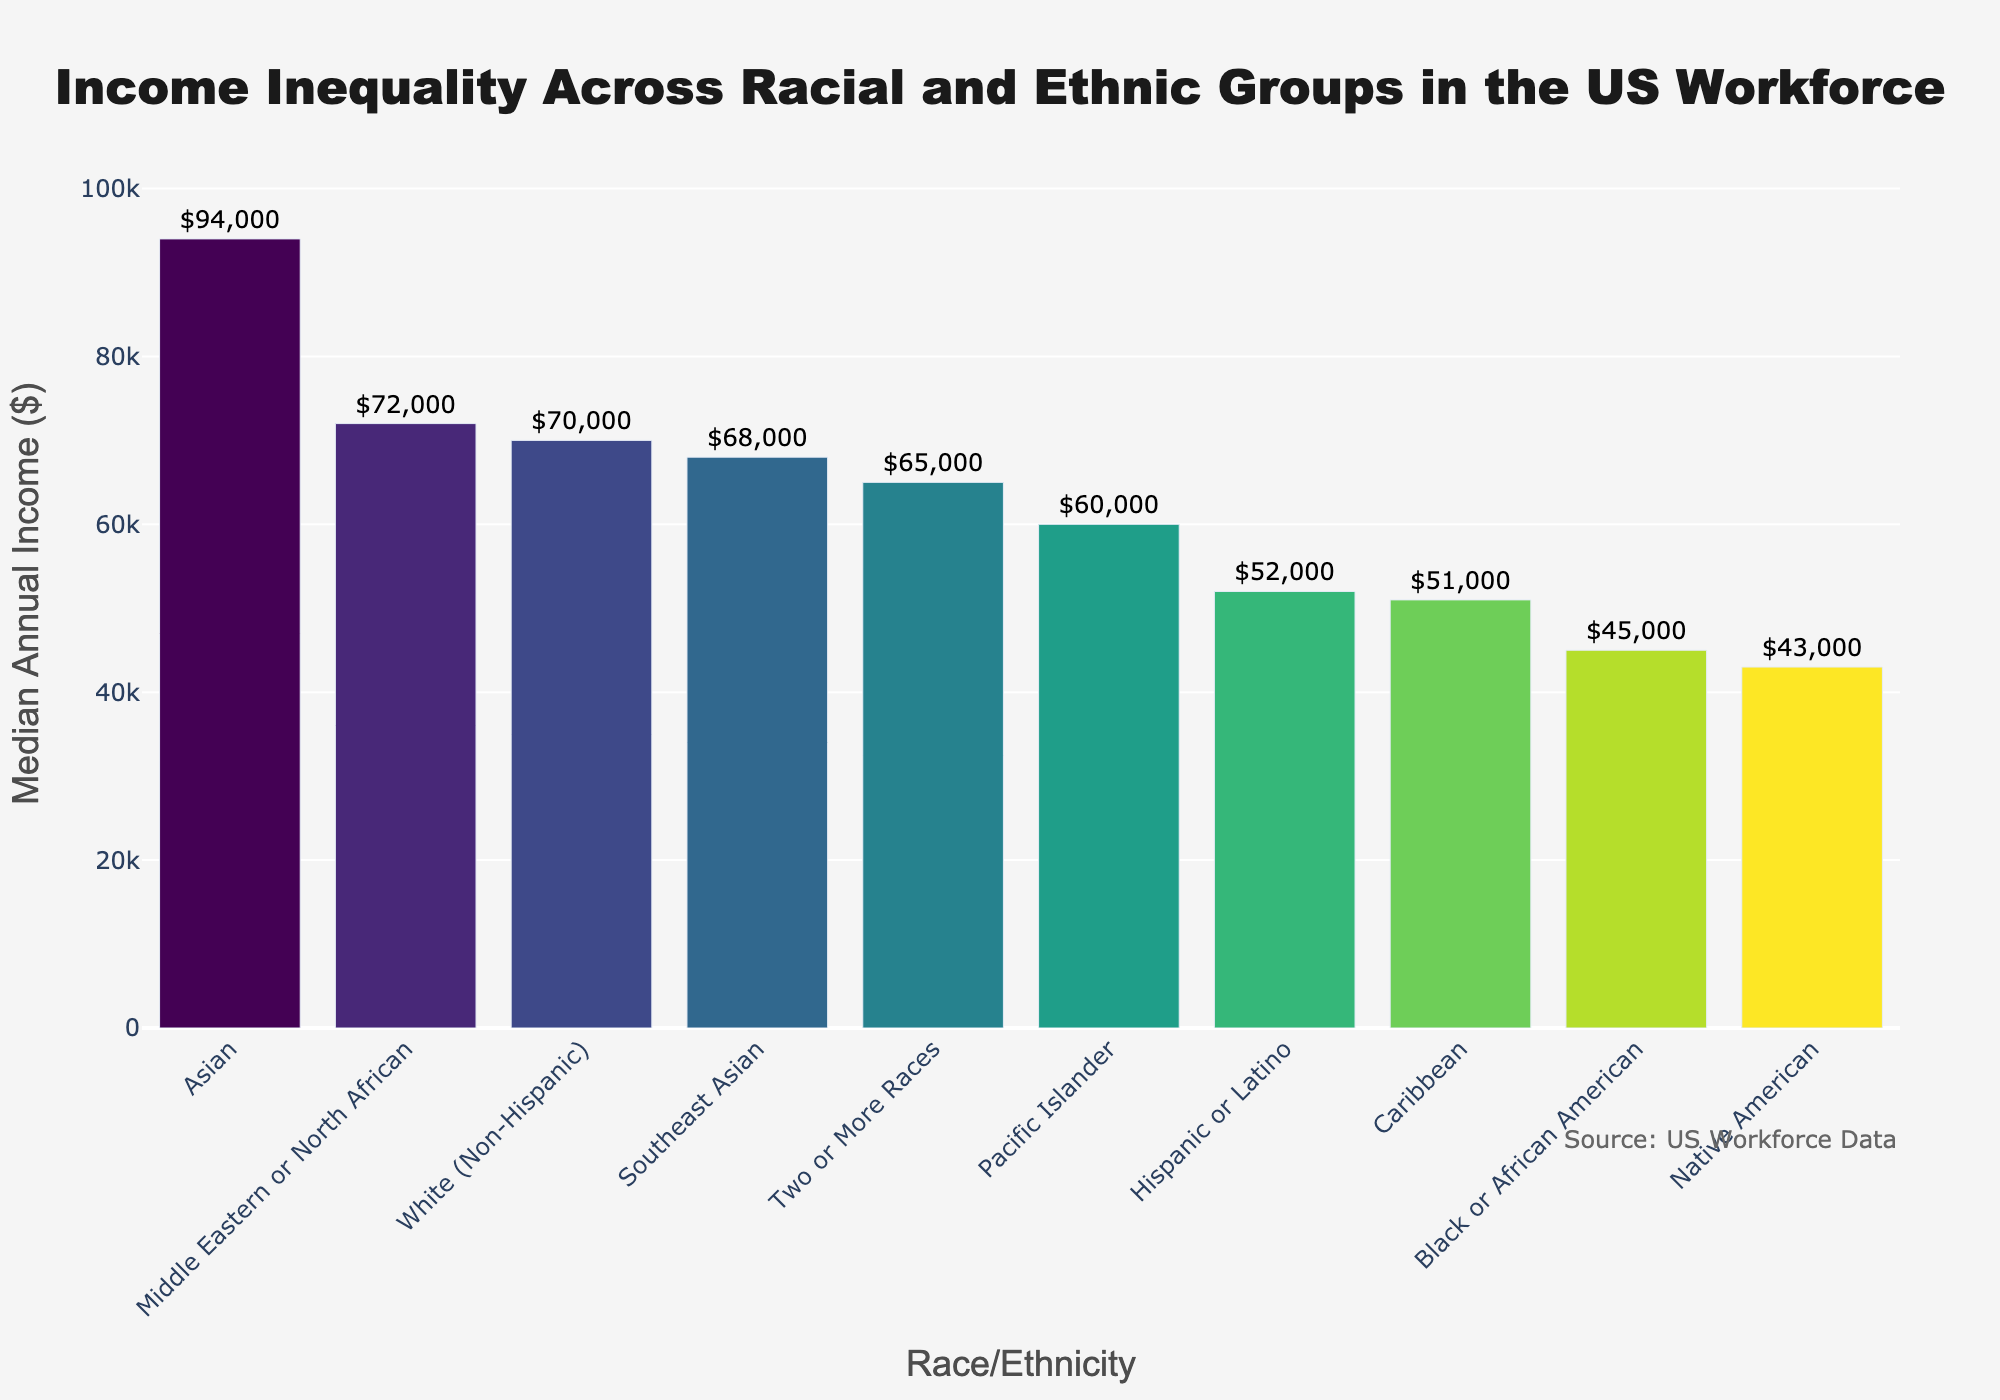Which racial or ethnic group has the highest median annual income? By observing the highest bar in the bar chart, we can identify the group with the highest median annual income. The tallest bar belongs to the Asian group, indicating that they have the highest median income.
Answer: Asian Which racial or ethnic group has the lowest median annual income? By looking at the shortest bar in the chart, one can determine the group with the lowest median annual income. The shortest bar is associated with Native American, indicating they have the lowest median income.
Answer: Native American What is the difference in median income between the group with the highest income and the group with the lowest income? The group with the highest median annual income is Asian ($94,000) and the group with the lowest is Native American ($43,000). The difference is calculated as $94,000 - $43,000.
Answer: $51,000 Compare the median annual income of Hispanic or Latino and Native American groups. Which group has a higher income and by how much? From the chart, the median annual income for Hispanic or Latino is $52,000 and for Native American is $43,000. The difference is $52,000 - $43,000.
Answer: Hispanic or Latino by $9,000 What is the combined median income of the White (Non-Hispanic) and Black or African American groups? The median income for White (Non-Hispanic) is $70,000 and for Black or African American is $45,000. Summing these values gives $70,000 + $45,000.
Answer: $115,000 Which group has a median income closest to the overall median when considering all groups? First, arrange the median incomes in ascending order: $43,000, $45,000, $51,000, $52,000, $60,000, $65,000, $68,000, $70,000, $72,000, $94,000. With 10 groups, the median would be the average of the 5th and 6th values in this list, i.e., ($60,000 + $65,000) / 2, which is closest to the income of Two or More Races.
Answer: Two or More Races Which groups have a median annual income greater than $65,000? Observing the chart, the groups with incomes higher than $65,000 are Two or More Races ($65,000 is equal), Southeast Asian ($68,000), White (Non-Hispanic) ($70,000), Middle Eastern or North African ($72,000), and Asian ($94,000).
Answer: Two or More Races, Southeast Asian, White (Non-Hispanic), Middle Eastern or North African, Asian How much more do Middle Eastern or North African individuals earn compared to Caribbean individuals? The median income for Middle Eastern or North African is $72,000 and for Caribbean is $51,000. The difference is $72,000 - $51,000.
Answer: $21,000 Which bars in the chart are taller than the bar representing Pacific Islander individuals? The median income for Pacific Islander is $60,000. The groups with bars taller than this value are Two or More Races, Southeast Asian, White (Non-Hispanic), Middle Eastern or North African, and Asian.
Answer: Two or More Races, Southeast Asian, White (Non-Hispanic), Middle Eastern or North African, Asian 